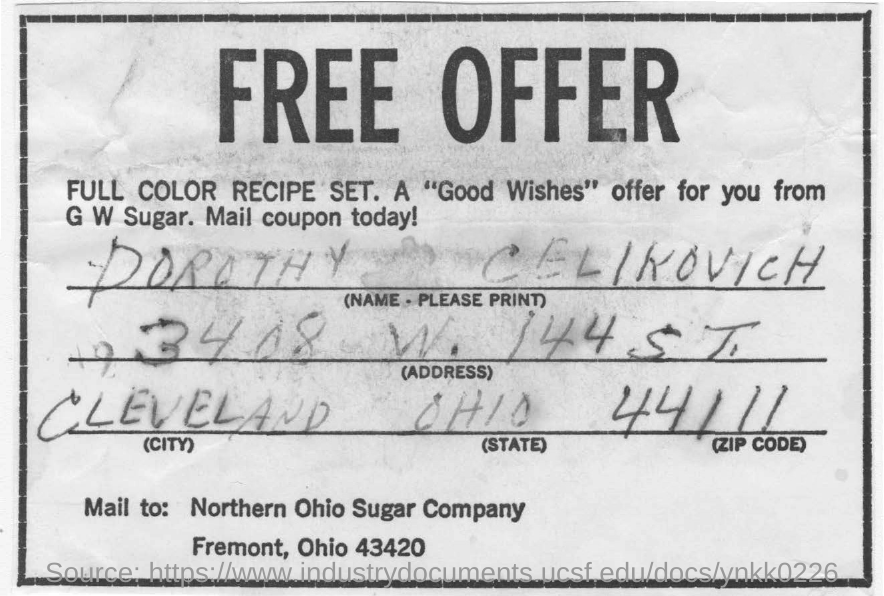Identify some key points in this picture. The address written in the form is 3408 West 144 South Street. The person's name in the document is Dorothy Celikovich. The ZIP code is 44111. 